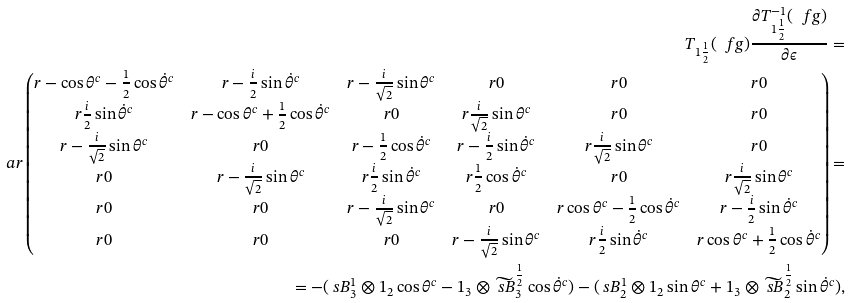Convert formula to latex. <formula><loc_0><loc_0><loc_500><loc_500>T _ { 1 \frac { 1 } { 2 } } ( \ f g ) \frac { \partial T ^ { - 1 } _ { 1 \frac { 1 } { 2 } } ( \ f g ) } { \partial \epsilon } = \\ \ a r \begin{pmatrix} r - \cos \theta ^ { c } - \frac { 1 } { 2 } \cos \dot { \theta } ^ { c } & r - \frac { i } { 2 } \sin \dot { \theta } ^ { c } & r - \frac { i } { \sqrt { 2 } } \sin \theta ^ { c } & r 0 & r 0 & r 0 \\ r \frac { i } { 2 } \sin \dot { \theta } ^ { c } & r - \cos \theta ^ { c } + \frac { 1 } { 2 } \cos \dot { \theta } ^ { c } & r 0 & r \frac { i } { \sqrt { 2 } } \sin \theta ^ { c } & r 0 & r 0 \\ r - \frac { i } { \sqrt { 2 } } \sin \theta ^ { c } & r 0 & r - \frac { 1 } { 2 } \cos \dot { \theta } ^ { c } & r - \frac { i } { 2 } \sin \dot { \theta } ^ { c } & r \frac { i } { \sqrt { 2 } } \sin \theta ^ { c } & r 0 \\ r 0 & r - \frac { i } { \sqrt { 2 } } \sin \theta ^ { c } & r \frac { i } { 2 } \sin \dot { \theta } ^ { c } & r \frac { 1 } { 2 } \cos \dot { \theta } ^ { c } & r 0 & r \frac { i } { \sqrt { 2 } } \sin \theta ^ { c } \\ r 0 & r 0 & r - \frac { i } { \sqrt { 2 } } \sin \theta ^ { c } & r 0 & r \cos \theta ^ { c } - \frac { 1 } { 2 } \cos \dot { \theta } ^ { c } & r - \frac { i } { 2 } \sin \dot { \theta } ^ { c } \\ r 0 & r 0 & r 0 & r - \frac { i } { \sqrt { 2 } } \sin \theta ^ { c } & r \frac { i } { 2 } \sin \dot { \theta } ^ { c } & r \cos \theta ^ { c } + \frac { 1 } { 2 } \cos \dot { \theta } ^ { c } \end{pmatrix} = \\ = - ( \ s B ^ { 1 } _ { 3 } \otimes 1 _ { 2 } \cos \theta ^ { c } - 1 _ { 3 } \otimes \widetilde { \ s B } ^ { \frac { 1 } { 2 } } _ { 3 } \cos \dot { \theta } ^ { c } ) - ( \ s B ^ { 1 } _ { 2 } \otimes 1 _ { 2 } \sin \theta ^ { c } + 1 _ { 3 } \otimes \widetilde { \ s B } ^ { \frac { 1 } { 2 } } _ { 2 } \sin \dot { \theta } ^ { c } ) ,</formula> 